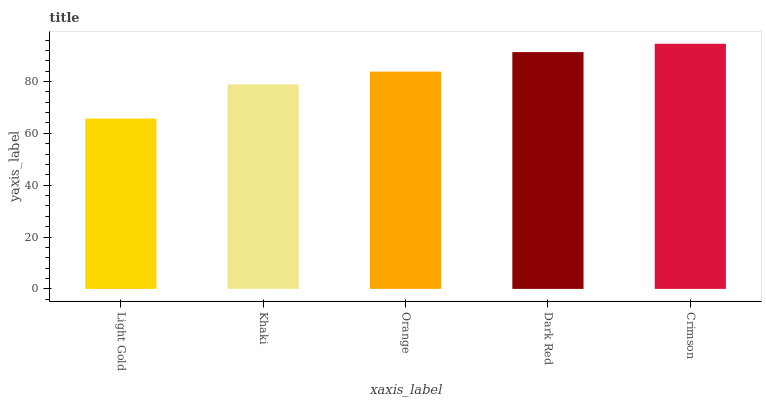Is Light Gold the minimum?
Answer yes or no. Yes. Is Crimson the maximum?
Answer yes or no. Yes. Is Khaki the minimum?
Answer yes or no. No. Is Khaki the maximum?
Answer yes or no. No. Is Khaki greater than Light Gold?
Answer yes or no. Yes. Is Light Gold less than Khaki?
Answer yes or no. Yes. Is Light Gold greater than Khaki?
Answer yes or no. No. Is Khaki less than Light Gold?
Answer yes or no. No. Is Orange the high median?
Answer yes or no. Yes. Is Orange the low median?
Answer yes or no. Yes. Is Khaki the high median?
Answer yes or no. No. Is Crimson the low median?
Answer yes or no. No. 